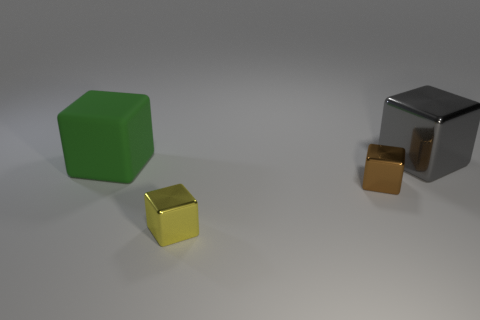Does the tiny yellow shiny object have the same shape as the gray object?
Your answer should be very brief. Yes. Are there any green objects behind the big thing to the left of the shiny thing behind the rubber thing?
Provide a succinct answer. No. There is a metal cube that is behind the large green cube; is it the same size as the metal cube in front of the small brown block?
Offer a terse response. No. Are there the same number of big green cubes right of the brown metallic block and big cubes in front of the small yellow thing?
Give a very brief answer. Yes. Are there any other things that have the same material as the large gray object?
Your answer should be compact. Yes. Is the size of the gray metal object the same as the thing that is to the left of the yellow metallic cube?
Provide a short and direct response. Yes. What is the material of the big block that is to the left of the thing that is to the right of the brown object?
Provide a short and direct response. Rubber. Are there the same number of large green things that are in front of the large green object and purple matte blocks?
Give a very brief answer. Yes. What is the size of the thing that is both to the right of the large matte block and behind the small brown shiny object?
Keep it short and to the point. Large. There is a large block behind the big cube in front of the big gray block; what is its color?
Offer a terse response. Gray. 